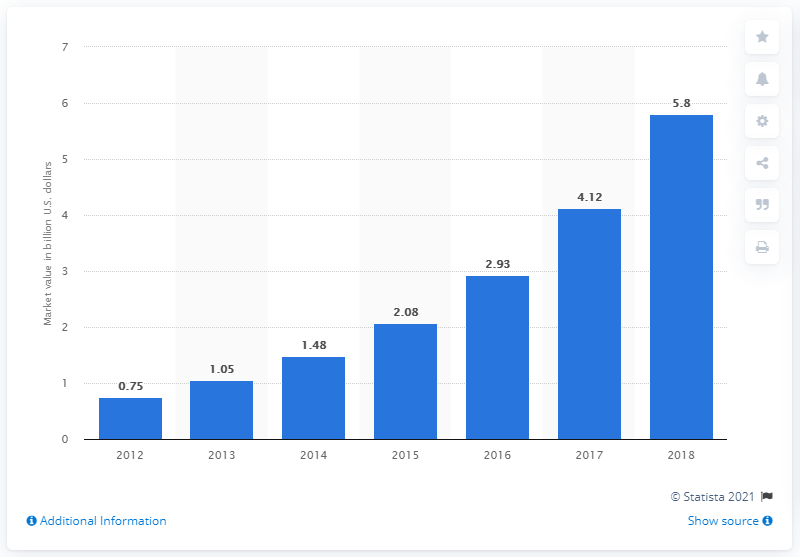Indicate a few pertinent items in this graphic. The global wearable devices market was projected to reach a value of approximately 5.8 billion dollars in 2018. 